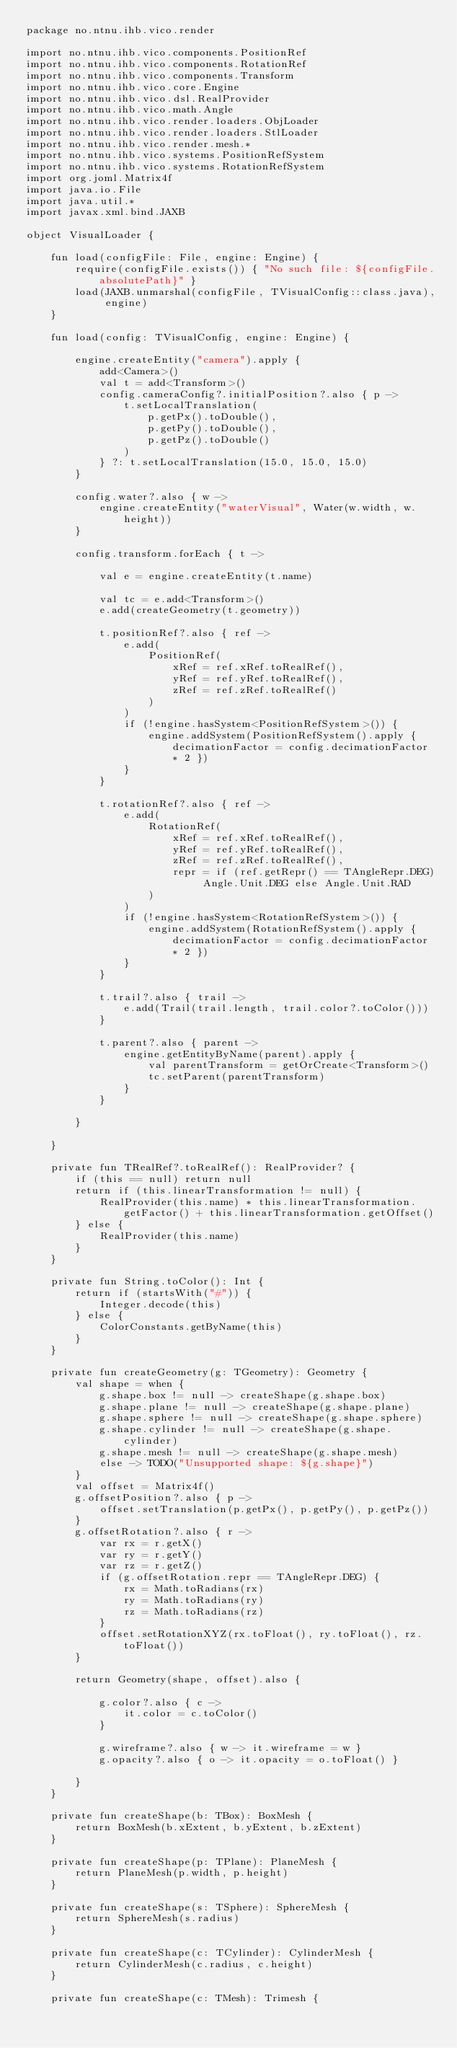Convert code to text. <code><loc_0><loc_0><loc_500><loc_500><_Kotlin_>package no.ntnu.ihb.vico.render

import no.ntnu.ihb.vico.components.PositionRef
import no.ntnu.ihb.vico.components.RotationRef
import no.ntnu.ihb.vico.components.Transform
import no.ntnu.ihb.vico.core.Engine
import no.ntnu.ihb.vico.dsl.RealProvider
import no.ntnu.ihb.vico.math.Angle
import no.ntnu.ihb.vico.render.loaders.ObjLoader
import no.ntnu.ihb.vico.render.loaders.StlLoader
import no.ntnu.ihb.vico.render.mesh.*
import no.ntnu.ihb.vico.systems.PositionRefSystem
import no.ntnu.ihb.vico.systems.RotationRefSystem
import org.joml.Matrix4f
import java.io.File
import java.util.*
import javax.xml.bind.JAXB

object VisualLoader {

    fun load(configFile: File, engine: Engine) {
        require(configFile.exists()) { "No such file: ${configFile.absolutePath}" }
        load(JAXB.unmarshal(configFile, TVisualConfig::class.java), engine)
    }

    fun load(config: TVisualConfig, engine: Engine) {

        engine.createEntity("camera").apply {
            add<Camera>()
            val t = add<Transform>()
            config.cameraConfig?.initialPosition?.also { p ->
                t.setLocalTranslation(
                    p.getPx().toDouble(),
                    p.getPy().toDouble(),
                    p.getPz().toDouble()
                )
            } ?: t.setLocalTranslation(15.0, 15.0, 15.0)
        }

        config.water?.also { w ->
            engine.createEntity("waterVisual", Water(w.width, w.height))
        }

        config.transform.forEach { t ->

            val e = engine.createEntity(t.name)

            val tc = e.add<Transform>()
            e.add(createGeometry(t.geometry))

            t.positionRef?.also { ref ->
                e.add(
                    PositionRef(
                        xRef = ref.xRef.toRealRef(),
                        yRef = ref.yRef.toRealRef(),
                        zRef = ref.zRef.toRealRef()
                    )
                )
                if (!engine.hasSystem<PositionRefSystem>()) {
                    engine.addSystem(PositionRefSystem().apply { decimationFactor = config.decimationFactor * 2 })
                }
            }

            t.rotationRef?.also { ref ->
                e.add(
                    RotationRef(
                        xRef = ref.xRef.toRealRef(),
                        yRef = ref.yRef.toRealRef(),
                        zRef = ref.zRef.toRealRef(),
                        repr = if (ref.getRepr() == TAngleRepr.DEG) Angle.Unit.DEG else Angle.Unit.RAD
                    )
                )
                if (!engine.hasSystem<RotationRefSystem>()) {
                    engine.addSystem(RotationRefSystem().apply { decimationFactor = config.decimationFactor * 2 })
                }
            }

            t.trail?.also { trail ->
                e.add(Trail(trail.length, trail.color?.toColor()))
            }

            t.parent?.also { parent ->
                engine.getEntityByName(parent).apply {
                    val parentTransform = getOrCreate<Transform>()
                    tc.setParent(parentTransform)
                }
            }

        }

    }

    private fun TRealRef?.toRealRef(): RealProvider? {
        if (this == null) return null
        return if (this.linearTransformation != null) {
            RealProvider(this.name) * this.linearTransformation.getFactor() + this.linearTransformation.getOffset()
        } else {
            RealProvider(this.name)
        }
    }

    private fun String.toColor(): Int {
        return if (startsWith("#")) {
            Integer.decode(this)
        } else {
            ColorConstants.getByName(this)
        }
    }

    private fun createGeometry(g: TGeometry): Geometry {
        val shape = when {
            g.shape.box != null -> createShape(g.shape.box)
            g.shape.plane != null -> createShape(g.shape.plane)
            g.shape.sphere != null -> createShape(g.shape.sphere)
            g.shape.cylinder != null -> createShape(g.shape.cylinder)
            g.shape.mesh != null -> createShape(g.shape.mesh)
            else -> TODO("Unsupported shape: ${g.shape}")
        }
        val offset = Matrix4f()
        g.offsetPosition?.also { p ->
            offset.setTranslation(p.getPx(), p.getPy(), p.getPz())
        }
        g.offsetRotation?.also { r ->
            var rx = r.getX()
            var ry = r.getY()
            var rz = r.getZ()
            if (g.offsetRotation.repr == TAngleRepr.DEG) {
                rx = Math.toRadians(rx)
                ry = Math.toRadians(ry)
                rz = Math.toRadians(rz)
            }
            offset.setRotationXYZ(rx.toFloat(), ry.toFloat(), rz.toFloat())
        }

        return Geometry(shape, offset).also {

            g.color?.also { c ->
                it.color = c.toColor()
            }

            g.wireframe?.also { w -> it.wireframe = w }
            g.opacity?.also { o -> it.opacity = o.toFloat() }

        }
    }

    private fun createShape(b: TBox): BoxMesh {
        return BoxMesh(b.xExtent, b.yExtent, b.zExtent)
    }

    private fun createShape(p: TPlane): PlaneMesh {
        return PlaneMesh(p.width, p.height)
    }

    private fun createShape(s: TSphere): SphereMesh {
        return SphereMesh(s.radius)
    }

    private fun createShape(c: TCylinder): CylinderMesh {
        return CylinderMesh(c.radius, c.height)
    }

    private fun createShape(c: TMesh): Trimesh {</code> 